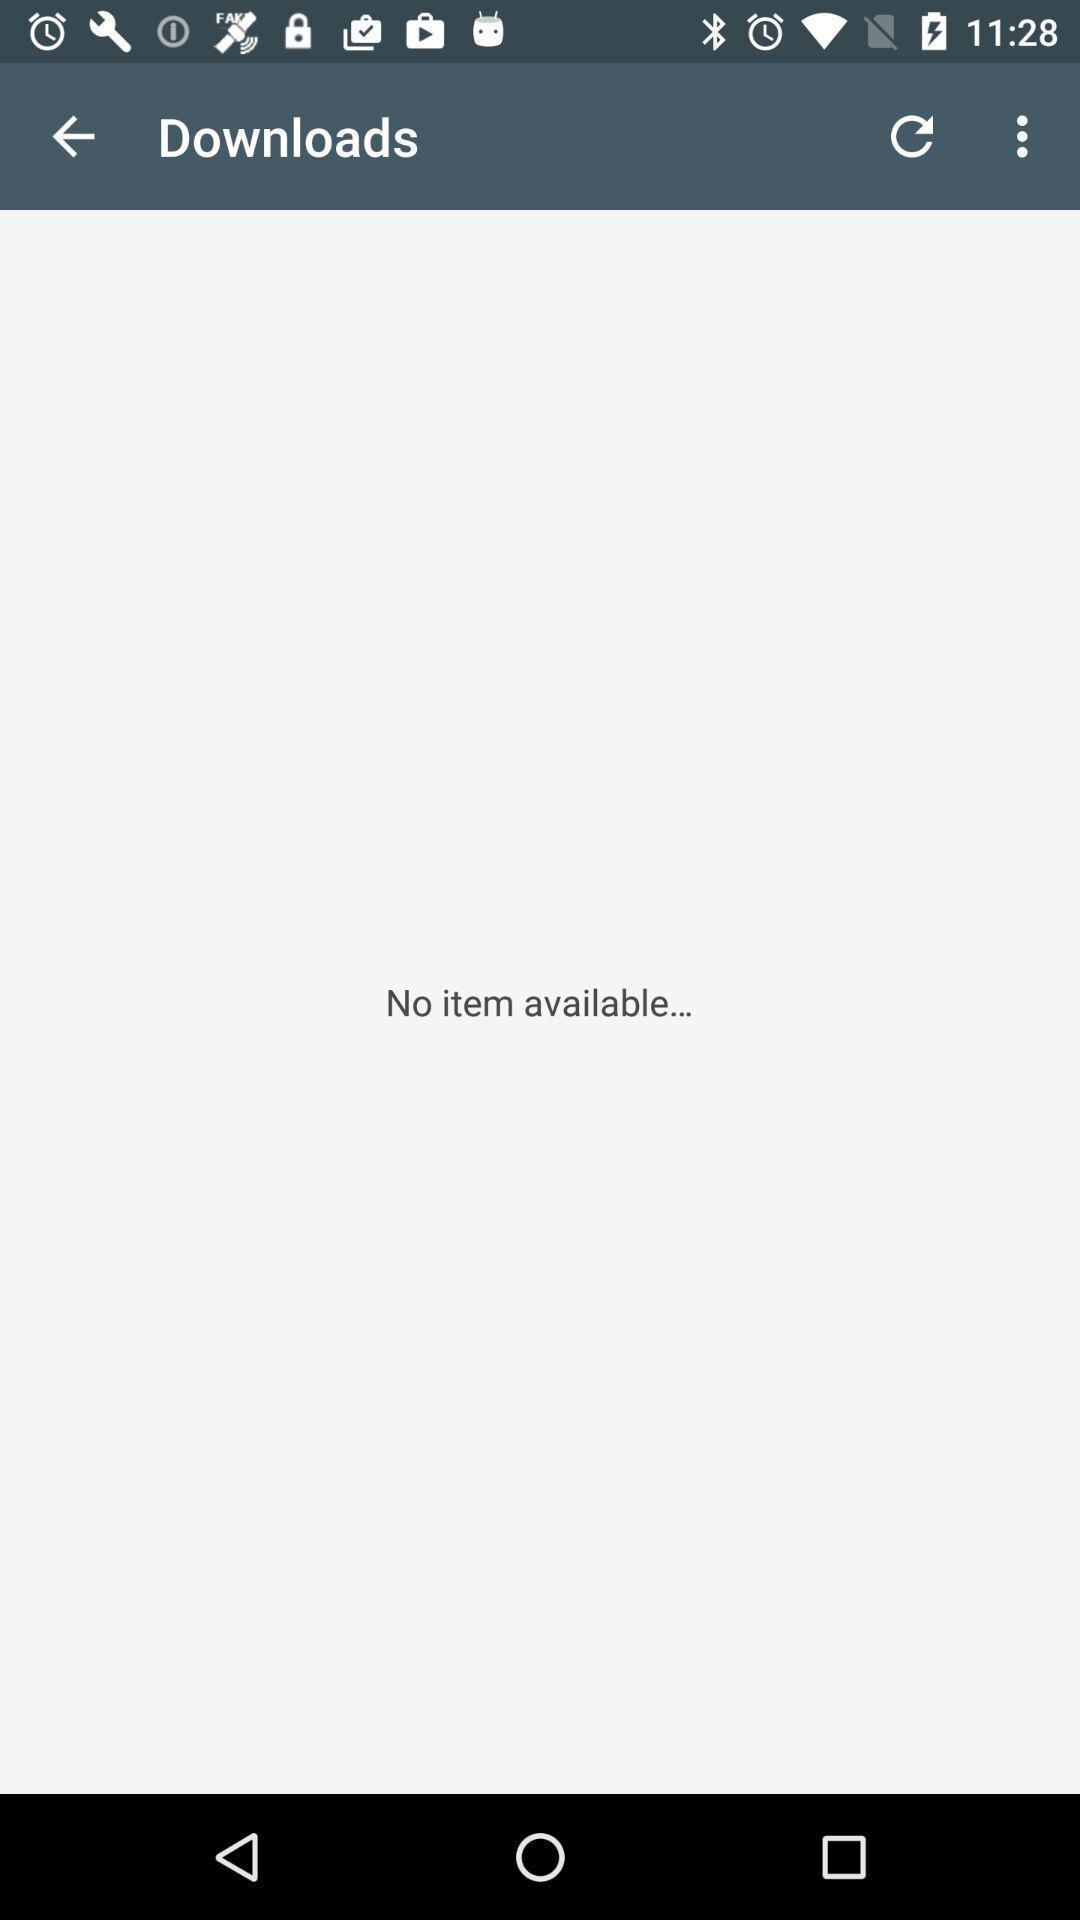Describe this image in words. Screen displaying no items available for download. 